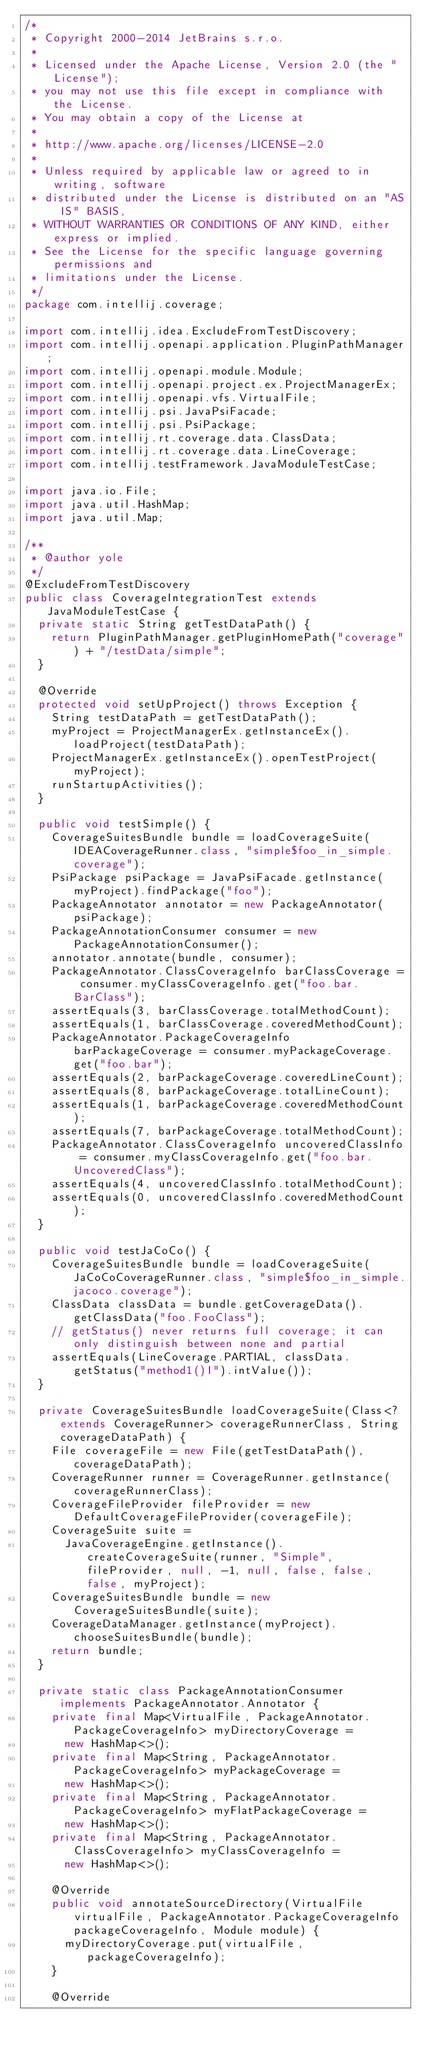Convert code to text. <code><loc_0><loc_0><loc_500><loc_500><_Java_>/*
 * Copyright 2000-2014 JetBrains s.r.o.
 *
 * Licensed under the Apache License, Version 2.0 (the "License");
 * you may not use this file except in compliance with the License.
 * You may obtain a copy of the License at
 *
 * http://www.apache.org/licenses/LICENSE-2.0
 *
 * Unless required by applicable law or agreed to in writing, software
 * distributed under the License is distributed on an "AS IS" BASIS,
 * WITHOUT WARRANTIES OR CONDITIONS OF ANY KIND, either express or implied.
 * See the License for the specific language governing permissions and
 * limitations under the License.
 */
package com.intellij.coverage;

import com.intellij.idea.ExcludeFromTestDiscovery;
import com.intellij.openapi.application.PluginPathManager;
import com.intellij.openapi.module.Module;
import com.intellij.openapi.project.ex.ProjectManagerEx;
import com.intellij.openapi.vfs.VirtualFile;
import com.intellij.psi.JavaPsiFacade;
import com.intellij.psi.PsiPackage;
import com.intellij.rt.coverage.data.ClassData;
import com.intellij.rt.coverage.data.LineCoverage;
import com.intellij.testFramework.JavaModuleTestCase;

import java.io.File;
import java.util.HashMap;
import java.util.Map;

/**
 * @author yole
 */
@ExcludeFromTestDiscovery
public class CoverageIntegrationTest extends JavaModuleTestCase {
  private static String getTestDataPath() {
    return PluginPathManager.getPluginHomePath("coverage") + "/testData/simple";
  }

  @Override
  protected void setUpProject() throws Exception {
    String testDataPath = getTestDataPath();
    myProject = ProjectManagerEx.getInstanceEx().loadProject(testDataPath);
    ProjectManagerEx.getInstanceEx().openTestProject(myProject);
    runStartupActivities();
  }

  public void testSimple() {
    CoverageSuitesBundle bundle = loadCoverageSuite(IDEACoverageRunner.class, "simple$foo_in_simple.coverage");
    PsiPackage psiPackage = JavaPsiFacade.getInstance(myProject).findPackage("foo");
    PackageAnnotator annotator = new PackageAnnotator(psiPackage);
    PackageAnnotationConsumer consumer = new PackageAnnotationConsumer();
    annotator.annotate(bundle, consumer);
    PackageAnnotator.ClassCoverageInfo barClassCoverage = consumer.myClassCoverageInfo.get("foo.bar.BarClass");
    assertEquals(3, barClassCoverage.totalMethodCount);
    assertEquals(1, barClassCoverage.coveredMethodCount);
    PackageAnnotator.PackageCoverageInfo barPackageCoverage = consumer.myPackageCoverage.get("foo.bar");
    assertEquals(2, barPackageCoverage.coveredLineCount);
    assertEquals(8, barPackageCoverage.totalLineCount);
    assertEquals(1, barPackageCoverage.coveredMethodCount);
    assertEquals(7, barPackageCoverage.totalMethodCount);
    PackageAnnotator.ClassCoverageInfo uncoveredClassInfo = consumer.myClassCoverageInfo.get("foo.bar.UncoveredClass");
    assertEquals(4, uncoveredClassInfo.totalMethodCount);
    assertEquals(0, uncoveredClassInfo.coveredMethodCount);
  }

  public void testJaCoCo() {
    CoverageSuitesBundle bundle = loadCoverageSuite(JaCoCoCoverageRunner.class, "simple$foo_in_simple.jacoco.coverage");
    ClassData classData = bundle.getCoverageData().getClassData("foo.FooClass");
    // getStatus() never returns full coverage; it can only distinguish between none and partial
    assertEquals(LineCoverage.PARTIAL, classData.getStatus("method1()I").intValue());
  }

  private CoverageSuitesBundle loadCoverageSuite(Class<? extends CoverageRunner> coverageRunnerClass, String coverageDataPath) {
    File coverageFile = new File(getTestDataPath(), coverageDataPath);
    CoverageRunner runner = CoverageRunner.getInstance(coverageRunnerClass);
    CoverageFileProvider fileProvider = new DefaultCoverageFileProvider(coverageFile);
    CoverageSuite suite =
      JavaCoverageEngine.getInstance().createCoverageSuite(runner, "Simple", fileProvider, null, -1, null, false, false, false, myProject);
    CoverageSuitesBundle bundle = new CoverageSuitesBundle(suite);
    CoverageDataManager.getInstance(myProject).chooseSuitesBundle(bundle);
    return bundle;
  }

  private static class PackageAnnotationConsumer implements PackageAnnotator.Annotator {
    private final Map<VirtualFile, PackageAnnotator.PackageCoverageInfo> myDirectoryCoverage =
      new HashMap<>();
    private final Map<String, PackageAnnotator.PackageCoverageInfo> myPackageCoverage =
      new HashMap<>();
    private final Map<String, PackageAnnotator.PackageCoverageInfo> myFlatPackageCoverage =
      new HashMap<>();
    private final Map<String, PackageAnnotator.ClassCoverageInfo> myClassCoverageInfo =
      new HashMap<>();

    @Override
    public void annotateSourceDirectory(VirtualFile virtualFile, PackageAnnotator.PackageCoverageInfo packageCoverageInfo, Module module) {
      myDirectoryCoverage.put(virtualFile, packageCoverageInfo);
    }

    @Override</code> 